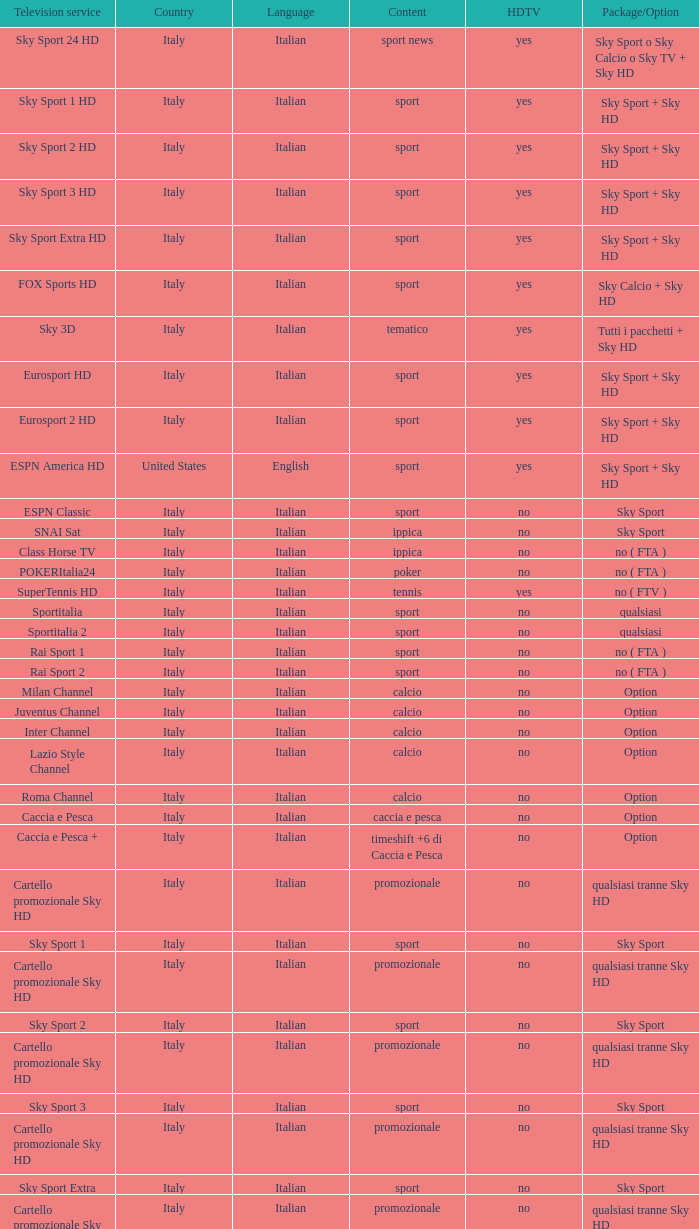What is speech, when subject is athletics, when high-definition tv is no, and when tv service is espn america? Italian. Can you parse all the data within this table? {'header': ['Television service', 'Country', 'Language', 'Content', 'HDTV', 'Package/Option'], 'rows': [['Sky Sport 24 HD', 'Italy', 'Italian', 'sport news', 'yes', 'Sky Sport o Sky Calcio o Sky TV + Sky HD'], ['Sky Sport 1 HD', 'Italy', 'Italian', 'sport', 'yes', 'Sky Sport + Sky HD'], ['Sky Sport 2 HD', 'Italy', 'Italian', 'sport', 'yes', 'Sky Sport + Sky HD'], ['Sky Sport 3 HD', 'Italy', 'Italian', 'sport', 'yes', 'Sky Sport + Sky HD'], ['Sky Sport Extra HD', 'Italy', 'Italian', 'sport', 'yes', 'Sky Sport + Sky HD'], ['FOX Sports HD', 'Italy', 'Italian', 'sport', 'yes', 'Sky Calcio + Sky HD'], ['Sky 3D', 'Italy', 'Italian', 'tematico', 'yes', 'Tutti i pacchetti + Sky HD'], ['Eurosport HD', 'Italy', 'Italian', 'sport', 'yes', 'Sky Sport + Sky HD'], ['Eurosport 2 HD', 'Italy', 'Italian', 'sport', 'yes', 'Sky Sport + Sky HD'], ['ESPN America HD', 'United States', 'English', 'sport', 'yes', 'Sky Sport + Sky HD'], ['ESPN Classic', 'Italy', 'Italian', 'sport', 'no', 'Sky Sport'], ['SNAI Sat', 'Italy', 'Italian', 'ippica', 'no', 'Sky Sport'], ['Class Horse TV', 'Italy', 'Italian', 'ippica', 'no', 'no ( FTA )'], ['POKERItalia24', 'Italy', 'Italian', 'poker', 'no', 'no ( FTA )'], ['SuperTennis HD', 'Italy', 'Italian', 'tennis', 'yes', 'no ( FTV )'], ['Sportitalia', 'Italy', 'Italian', 'sport', 'no', 'qualsiasi'], ['Sportitalia 2', 'Italy', 'Italian', 'sport', 'no', 'qualsiasi'], ['Rai Sport 1', 'Italy', 'Italian', 'sport', 'no', 'no ( FTA )'], ['Rai Sport 2', 'Italy', 'Italian', 'sport', 'no', 'no ( FTA )'], ['Milan Channel', 'Italy', 'Italian', 'calcio', 'no', 'Option'], ['Juventus Channel', 'Italy', 'Italian', 'calcio', 'no', 'Option'], ['Inter Channel', 'Italy', 'Italian', 'calcio', 'no', 'Option'], ['Lazio Style Channel', 'Italy', 'Italian', 'calcio', 'no', 'Option'], ['Roma Channel', 'Italy', 'Italian', 'calcio', 'no', 'Option'], ['Caccia e Pesca', 'Italy', 'Italian', 'caccia e pesca', 'no', 'Option'], ['Caccia e Pesca +', 'Italy', 'Italian', 'timeshift +6 di Caccia e Pesca', 'no', 'Option'], ['Cartello promozionale Sky HD', 'Italy', 'Italian', 'promozionale', 'no', 'qualsiasi tranne Sky HD'], ['Sky Sport 1', 'Italy', 'Italian', 'sport', 'no', 'Sky Sport'], ['Cartello promozionale Sky HD', 'Italy', 'Italian', 'promozionale', 'no', 'qualsiasi tranne Sky HD'], ['Sky Sport 2', 'Italy', 'Italian', 'sport', 'no', 'Sky Sport'], ['Cartello promozionale Sky HD', 'Italy', 'Italian', 'promozionale', 'no', 'qualsiasi tranne Sky HD'], ['Sky Sport 3', 'Italy', 'Italian', 'sport', 'no', 'Sky Sport'], ['Cartello promozionale Sky HD', 'Italy', 'Italian', 'promozionale', 'no', 'qualsiasi tranne Sky HD'], ['Sky Sport Extra', 'Italy', 'Italian', 'sport', 'no', 'Sky Sport'], ['Cartello promozionale Sky HD', 'Italy', 'Italian', 'promozionale', 'no', 'qualsiasi tranne Sky HD'], ['Sky Supercalcio', 'Italy', 'Italian', 'calcio', 'no', 'Sky Calcio'], ['Cartello promozionale Sky HD', 'Italy', 'Italian', 'promozionale', 'no', 'qualsiasi tranne Sky HD'], ['Eurosport', 'Italy', 'Italian', 'sport', 'no', 'Sky Sport'], ['Eurosport 2', 'Italy', 'Italian', 'sport', 'no', 'Sky Sport'], ['ESPN America', 'Italy', 'Italian', 'sport', 'no', 'Sky Sport']]} 